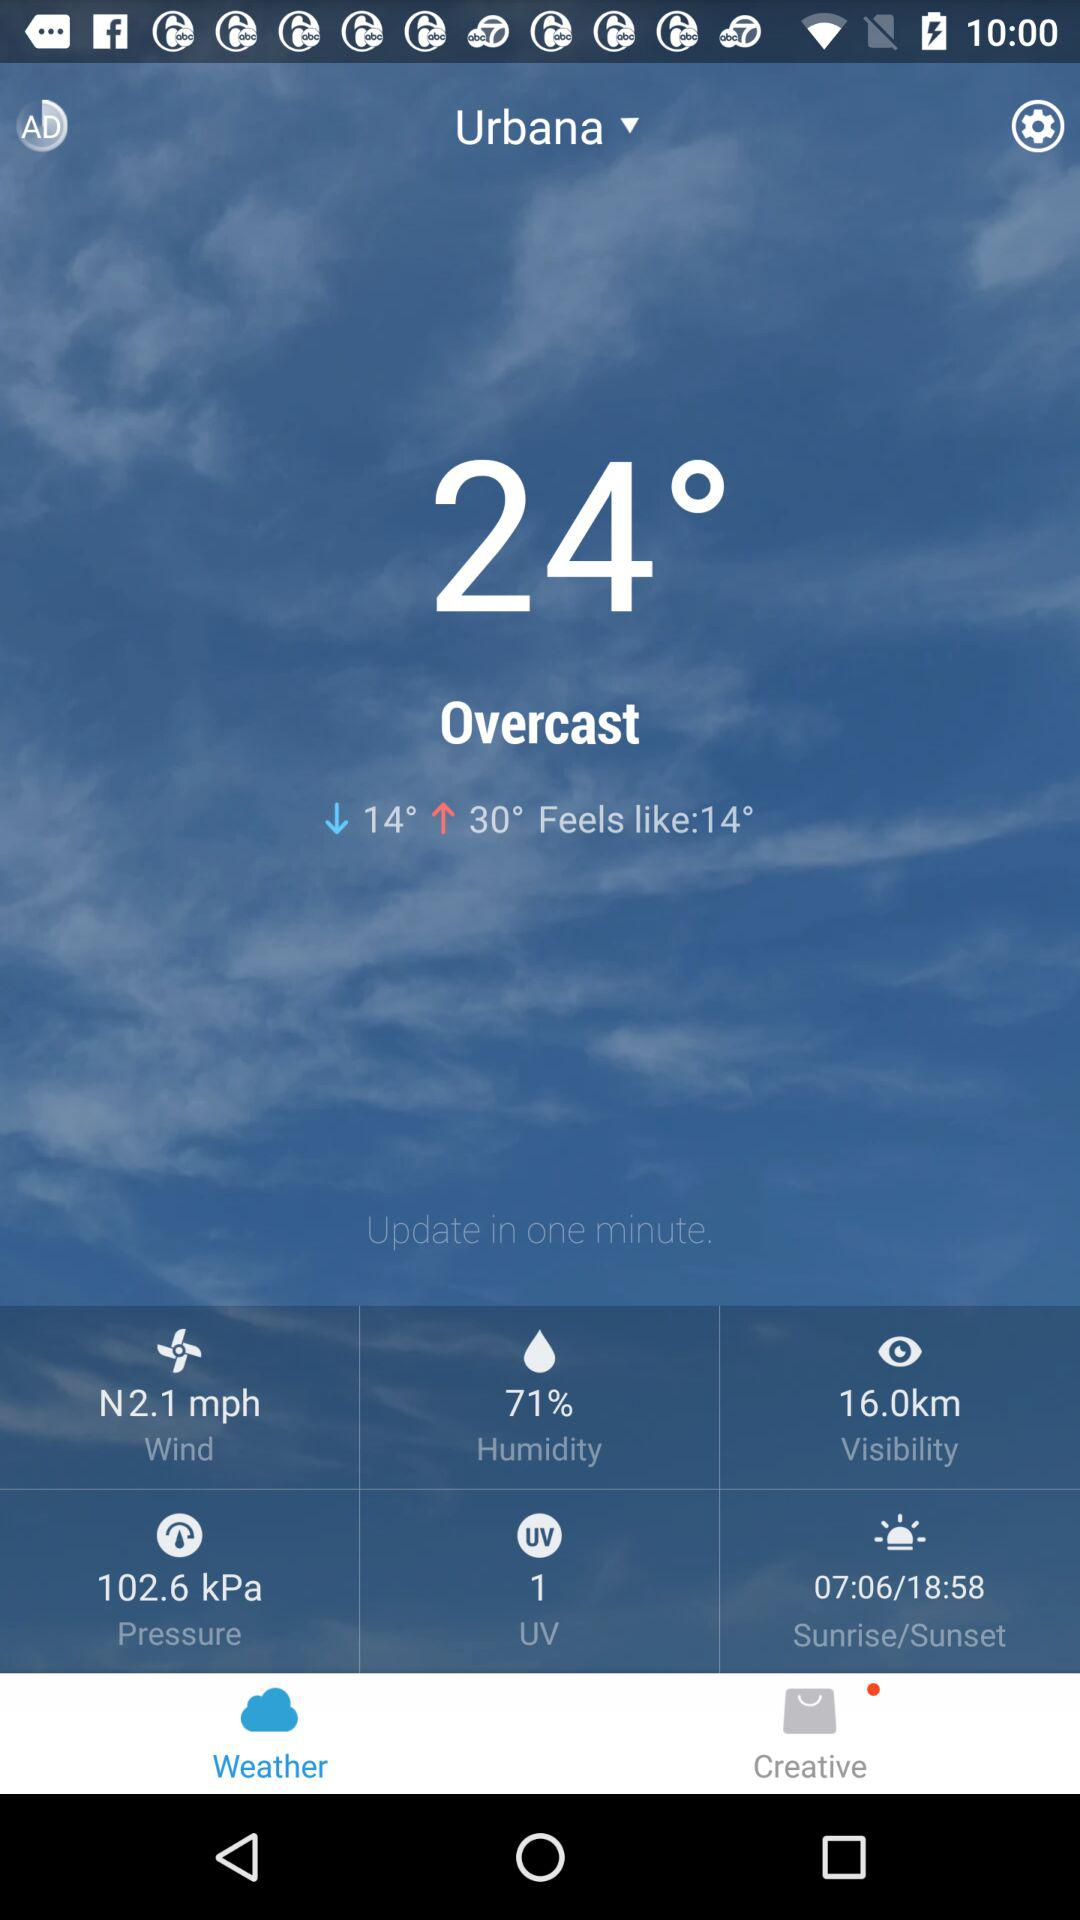What is the humidity in percent?
Answer the question using a single word or phrase. 71% 